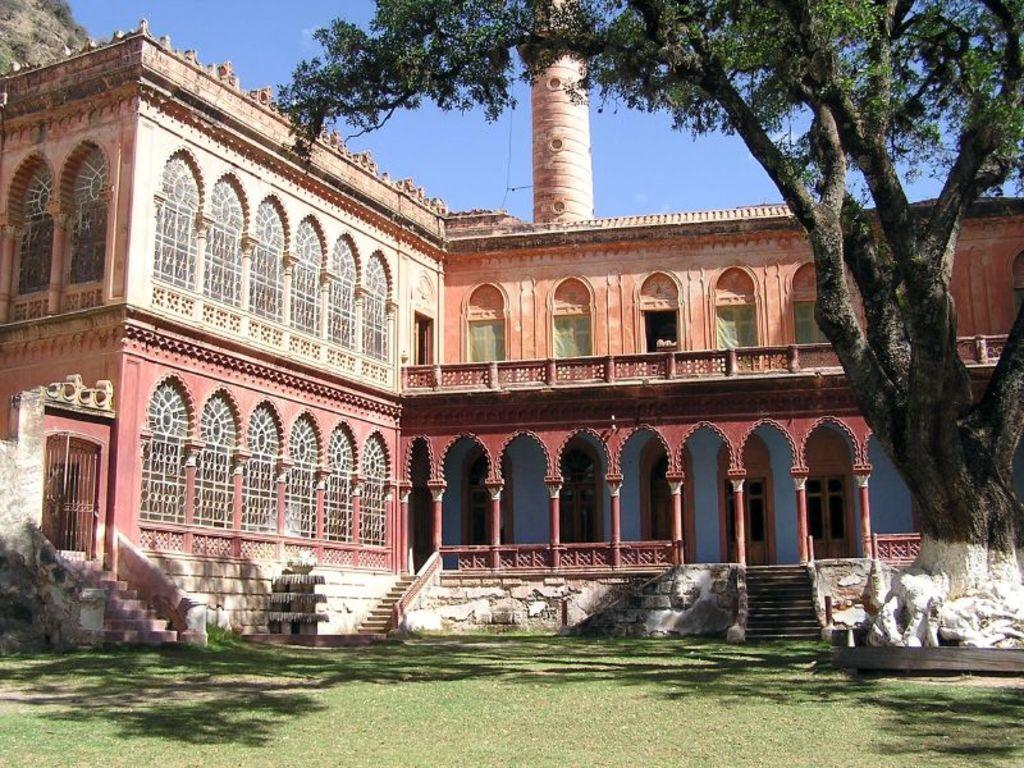What type of vegetation can be seen in the image? There is grass in the image. What architectural features are present in the image? There are pillars, steps, and a building in the image. What other natural elements can be seen in the image? There are trees in the image. What is visible in the background of the image? The sky is blue in the background of the image. How does the grass contribute to the quiet atmosphere in the image? The image does not convey any information about the atmosphere or noise level, so it is not possible to determine how the grass contributes to the quiet atmosphere. What role does the building play in the digestion process of the trees in the image? There is no information about the digestion process of the trees in the image, and the building does not appear to have any direct connection to the trees. 